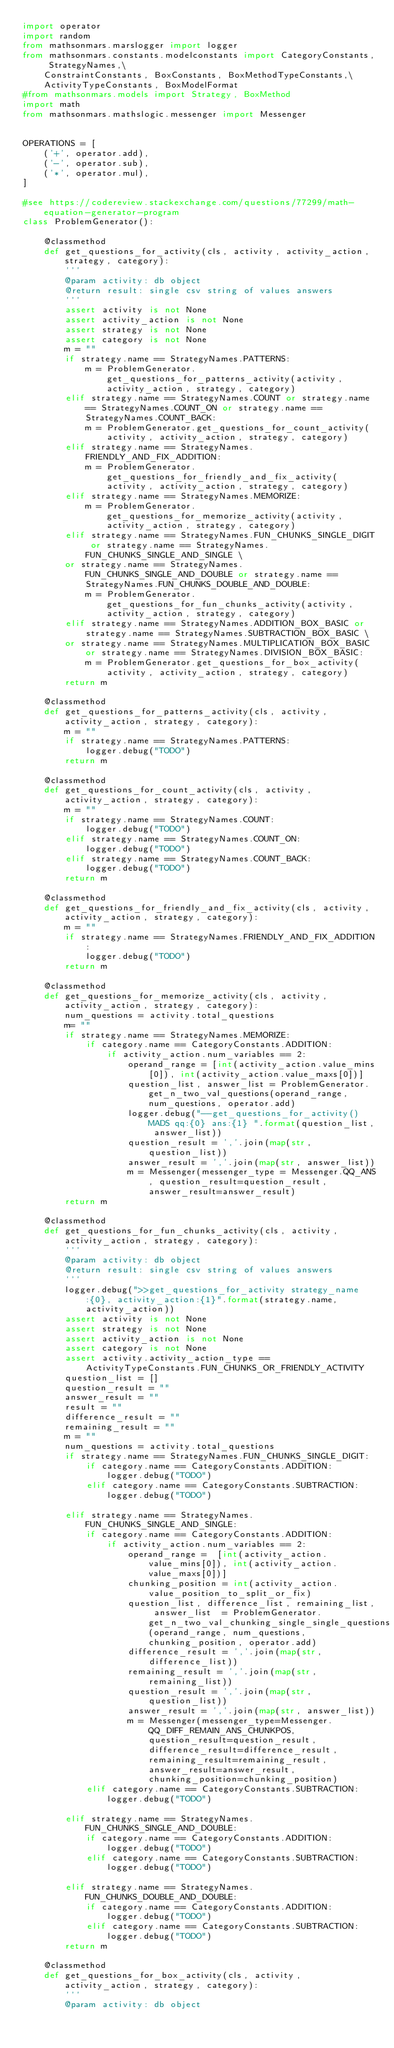Convert code to text. <code><loc_0><loc_0><loc_500><loc_500><_Python_>import operator
import random
from mathsonmars.marslogger import logger
from mathsonmars.constants.modelconstants import CategoryConstants, StrategyNames,\
    ConstraintConstants, BoxConstants, BoxMethodTypeConstants,\
    ActivityTypeConstants, BoxModelFormat
#from mathsonmars.models import Strategy, BoxMethod
import math
from mathsonmars.mathslogic.messenger import Messenger


OPERATIONS = [
    ('+', operator.add),
    ('-', operator.sub),
    ('*', operator.mul),
]

#see https://codereview.stackexchange.com/questions/77299/math-equation-generator-program
class ProblemGenerator():
    
    @classmethod
    def get_questions_for_activity(cls, activity, activity_action, strategy, category):
        '''
        @param activity: db object
        @return result: single csv string of values answers
        '''
        assert activity is not None
        assert activity_action is not None
        assert strategy is not None
        assert category is not None
        m = ""
        if strategy.name == StrategyNames.PATTERNS:
            m = ProblemGenerator.get_questions_for_patterns_activity(activity, activity_action, strategy, category)
        elif strategy.name == StrategyNames.COUNT or strategy.name == StrategyNames.COUNT_ON or strategy.name == StrategyNames.COUNT_BACK:
            m = ProblemGenerator.get_questions_for_count_activity(activity, activity_action, strategy, category)
        elif strategy.name == StrategyNames.FRIENDLY_AND_FIX_ADDITION:
            m = ProblemGenerator.get_questions_for_friendly_and_fix_activity(activity, activity_action, strategy, category)  
        elif strategy.name == StrategyNames.MEMORIZE:
            m = ProblemGenerator.get_questions_for_memorize_activity(activity, activity_action, strategy, category)
        elif strategy.name == StrategyNames.FUN_CHUNKS_SINGLE_DIGIT or strategy.name == StrategyNames.FUN_CHUNKS_SINGLE_AND_SINGLE \
        or strategy.name == StrategyNames.FUN_CHUNKS_SINGLE_AND_DOUBLE or strategy.name == StrategyNames.FUN_CHUNKS_DOUBLE_AND_DOUBLE:
            m = ProblemGenerator.get_questions_for_fun_chunks_activity(activity, activity_action, strategy, category)
        elif strategy.name == StrategyNames.ADDITION_BOX_BASIC or strategy.name == StrategyNames.SUBTRACTION_BOX_BASIC \
        or strategy.name == StrategyNames.MULTIPLICATION_BOX_BASIC or strategy.name == StrategyNames.DIVISION_BOX_BASIC:
            m = ProblemGenerator.get_questions_for_box_activity(activity, activity_action, strategy, category)
        return m

    @classmethod
    def get_questions_for_patterns_activity(cls, activity, activity_action, strategy, category):  
        m = ""
        if strategy.name == StrategyNames.PATTERNS:
            logger.debug("TODO")
        return m
    
    @classmethod
    def get_questions_for_count_activity(cls, activity, activity_action, strategy, category):                    
        m = ""
        if strategy.name == StrategyNames.COUNT:
            logger.debug("TODO")
        elif strategy.name == StrategyNames.COUNT_ON:
            logger.debug("TODO")
        elif strategy.name == StrategyNames.COUNT_BACK:
            logger.debug("TODO")
        return m
    
    @classmethod
    def get_questions_for_friendly_and_fix_activity(cls, activity, activity_action, strategy, category):
        m = ""
        if strategy.name == StrategyNames.FRIENDLY_AND_FIX_ADDITION:
            logger.debug("TODO")
        return m 
    
    @classmethod
    def get_questions_for_memorize_activity(cls, activity, activity_action, strategy, category):
        num_questions = activity.total_questions
        m= ""
        if strategy.name == StrategyNames.MEMORIZE:
            if category.name == CategoryConstants.ADDITION:
                if activity_action.num_variables == 2:
                    operand_range = [int(activity_action.value_mins[0]), int(activity_action.value_maxs[0])] 
                    question_list, answer_list = ProblemGenerator.get_n_two_val_questions(operand_range, num_questions, operator.add)
                    logger.debug("--get_questions_for_activity() MADS qq:{0} ans:{1} ".format(question_list, answer_list))
                    question_result = ','.join(map(str, question_list))
                    answer_result = ','.join(map(str, answer_list))
                    m = Messenger(messenger_type = Messenger.QQ_ANS, question_result=question_result, answer_result=answer_result)
        return m   
    
    @classmethod
    def get_questions_for_fun_chunks_activity(cls, activity, activity_action, strategy, category):
        '''
        @param activity: db object
        @return result: single csv string of values answers
        '''
        logger.debug(">>get_questions_for_activity strategy_name:{0}, activity_action:{1}".format(strategy.name, activity_action))
        assert activity is not None
        assert strategy is not None
        assert activity_action is not None
        assert category is not None
        assert activity.activity_action_type == ActivityTypeConstants.FUN_CHUNKS_OR_FRIENDLY_ACTIVITY
        question_list = []
        question_result = ""
        answer_result = ""
        result = ""
        difference_result = ""
        remaining_result = ""
        m = ""
        num_questions = activity.total_questions
        if strategy.name == StrategyNames.FUN_CHUNKS_SINGLE_DIGIT:
            if category.name == CategoryConstants.ADDITION:
                logger.debug("TODO")
            elif category.name == CategoryConstants.SUBTRACTION:
                logger.debug("TODO")
            
        elif strategy.name == StrategyNames.FUN_CHUNKS_SINGLE_AND_SINGLE:
            if category.name == CategoryConstants.ADDITION:
                if activity_action.num_variables == 2:
                    operand_range =  [int(activity_action.value_mins[0]), int(activity_action.value_maxs[0])] 
                    chunking_position = int(activity_action.value_position_to_split_or_fix)
                    question_list, difference_list, remaining_list, answer_list  = ProblemGenerator.get_n_two_val_chunking_single_single_questions(operand_range, num_questions, chunking_position, operator.add)
                    difference_result = ','.join(map(str, difference_list))
                    remaining_result = ','.join(map(str, remaining_list))
                    question_result = ','.join(map(str, question_list))
                    answer_result = ','.join(map(str, answer_list))
                    m = Messenger(messenger_type=Messenger.QQ_DIFF_REMAIN_ANS_CHUNKPOS, question_result=question_result, difference_result=difference_result, remaining_result=remaining_result, answer_result=answer_result, chunking_position=chunking_position)
            elif category.name == CategoryConstants.SUBTRACTION:
                logger.debug("TODO")
            
        elif strategy.name == StrategyNames.FUN_CHUNKS_SINGLE_AND_DOUBLE:
            if category.name == CategoryConstants.ADDITION:
                logger.debug("TODO")
            elif category.name == CategoryConstants.SUBTRACTION:
                logger.debug("TODO")
        
        elif strategy.name == StrategyNames.FUN_CHUNKS_DOUBLE_AND_DOUBLE:
            if category.name == CategoryConstants.ADDITION:
                logger.debug("TODO")
            elif category.name == CategoryConstants.SUBTRACTION:
                logger.debug("TODO")
        return m
       
    @classmethod
    def get_questions_for_box_activity(cls, activity, activity_action, strategy, category):
        '''
        @param activity: db object</code> 